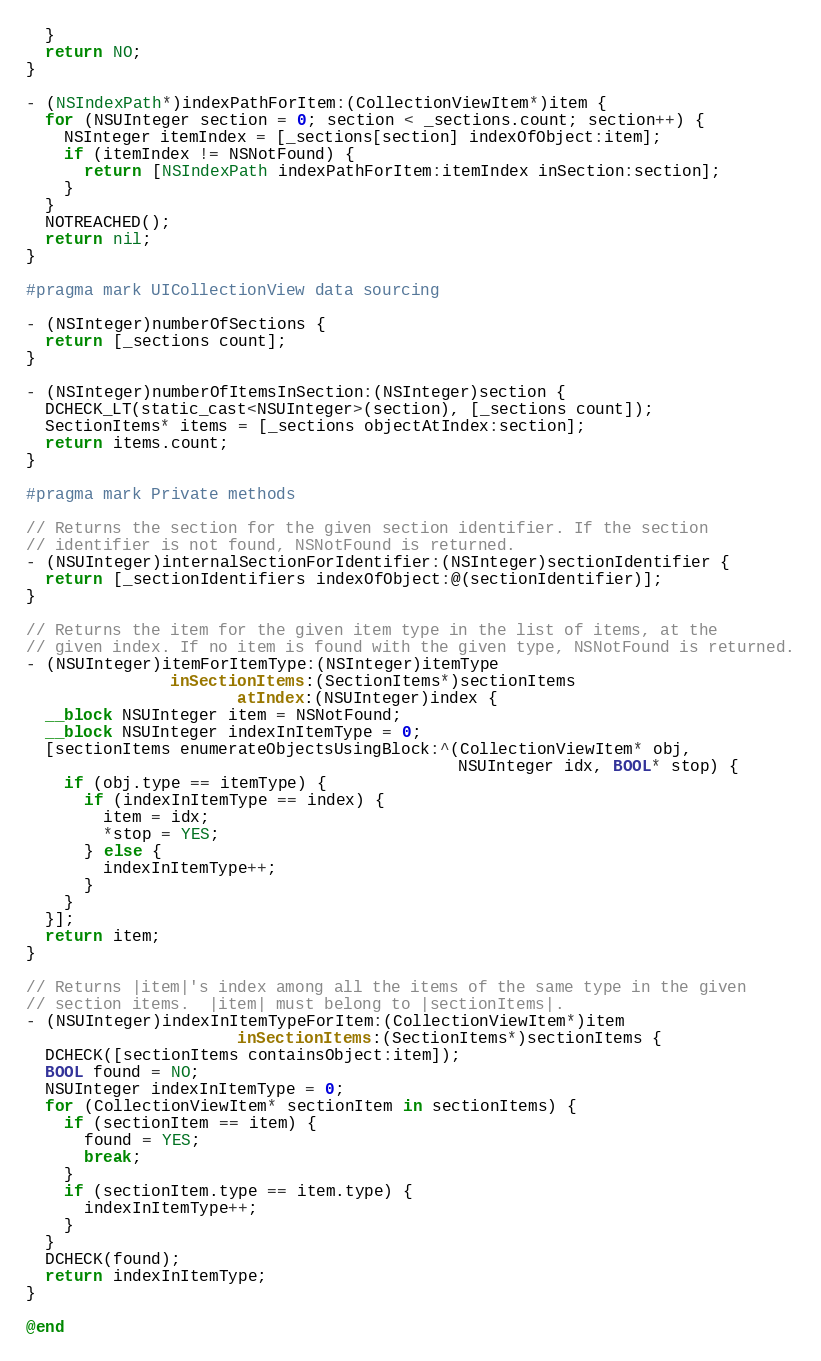<code> <loc_0><loc_0><loc_500><loc_500><_ObjectiveC_>  }
  return NO;
}

- (NSIndexPath*)indexPathForItem:(CollectionViewItem*)item {
  for (NSUInteger section = 0; section < _sections.count; section++) {
    NSInteger itemIndex = [_sections[section] indexOfObject:item];
    if (itemIndex != NSNotFound) {
      return [NSIndexPath indexPathForItem:itemIndex inSection:section];
    }
  }
  NOTREACHED();
  return nil;
}

#pragma mark UICollectionView data sourcing

- (NSInteger)numberOfSections {
  return [_sections count];
}

- (NSInteger)numberOfItemsInSection:(NSInteger)section {
  DCHECK_LT(static_cast<NSUInteger>(section), [_sections count]);
  SectionItems* items = [_sections objectAtIndex:section];
  return items.count;
}

#pragma mark Private methods

// Returns the section for the given section identifier. If the section
// identifier is not found, NSNotFound is returned.
- (NSUInteger)internalSectionForIdentifier:(NSInteger)sectionIdentifier {
  return [_sectionIdentifiers indexOfObject:@(sectionIdentifier)];
}

// Returns the item for the given item type in the list of items, at the
// given index. If no item is found with the given type, NSNotFound is returned.
- (NSUInteger)itemForItemType:(NSInteger)itemType
               inSectionItems:(SectionItems*)sectionItems
                      atIndex:(NSUInteger)index {
  __block NSUInteger item = NSNotFound;
  __block NSUInteger indexInItemType = 0;
  [sectionItems enumerateObjectsUsingBlock:^(CollectionViewItem* obj,
                                             NSUInteger idx, BOOL* stop) {
    if (obj.type == itemType) {
      if (indexInItemType == index) {
        item = idx;
        *stop = YES;
      } else {
        indexInItemType++;
      }
    }
  }];
  return item;
}

// Returns |item|'s index among all the items of the same type in the given
// section items.  |item| must belong to |sectionItems|.
- (NSUInteger)indexInItemTypeForItem:(CollectionViewItem*)item
                      inSectionItems:(SectionItems*)sectionItems {
  DCHECK([sectionItems containsObject:item]);
  BOOL found = NO;
  NSUInteger indexInItemType = 0;
  for (CollectionViewItem* sectionItem in sectionItems) {
    if (sectionItem == item) {
      found = YES;
      break;
    }
    if (sectionItem.type == item.type) {
      indexInItemType++;
    }
  }
  DCHECK(found);
  return indexInItemType;
}

@end
</code> 